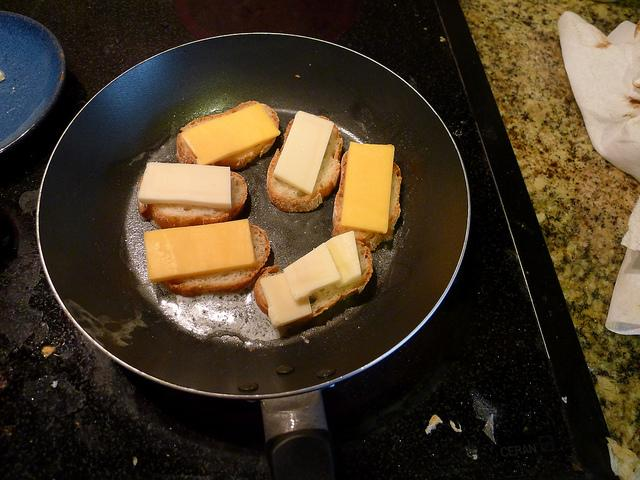What will happen to the yellow and white slices? Please explain your reasoning. will melt. The slices will melt. 